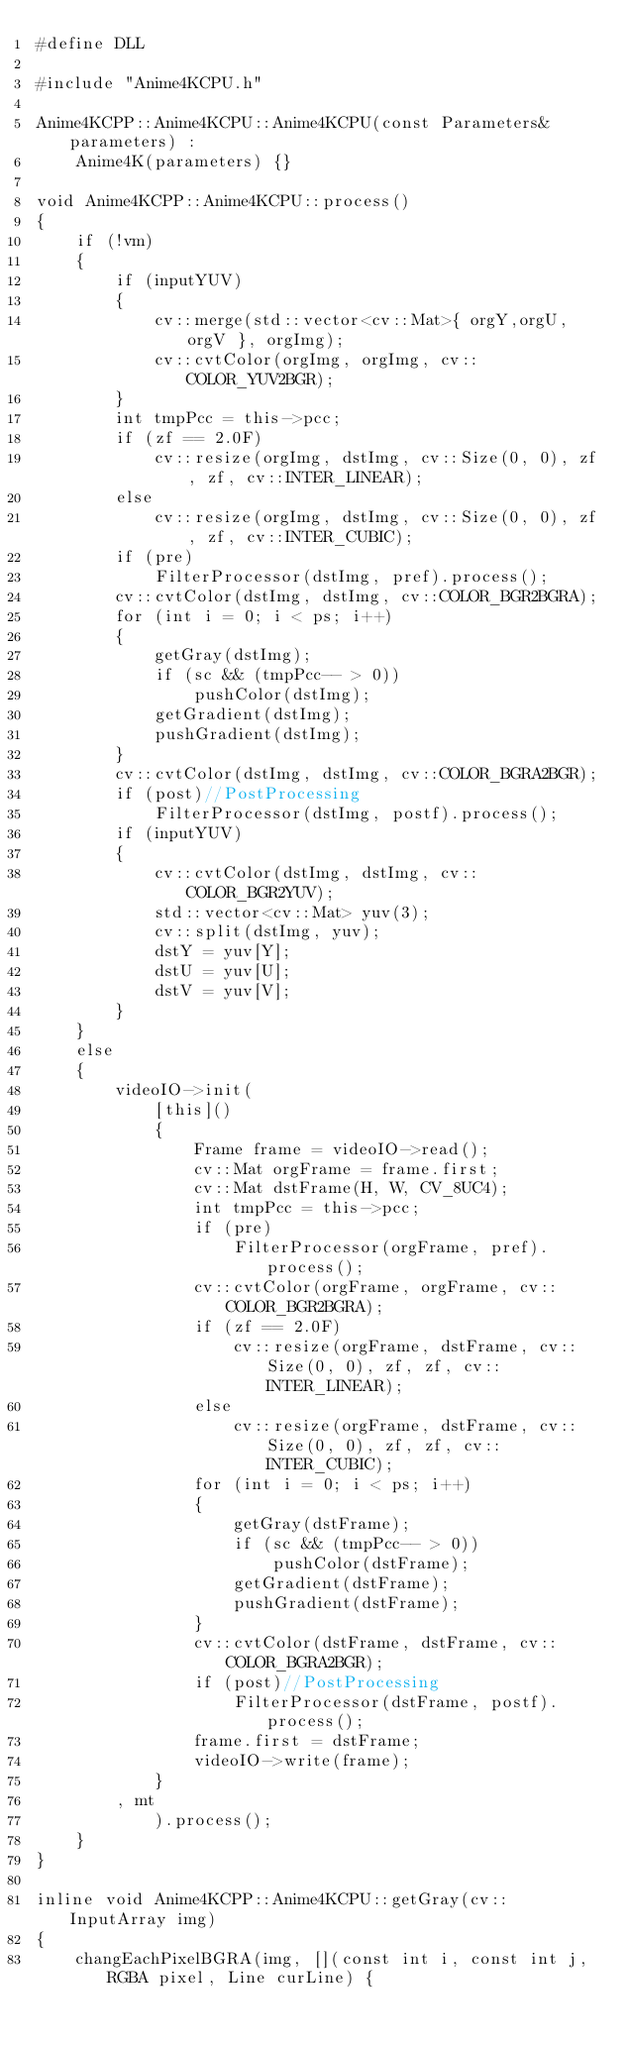<code> <loc_0><loc_0><loc_500><loc_500><_C++_>#define DLL

#include "Anime4KCPU.h"

Anime4KCPP::Anime4KCPU::Anime4KCPU(const Parameters& parameters) : 
    Anime4K(parameters) {}

void Anime4KCPP::Anime4KCPU::process()
{
    if (!vm)
    {
        if (inputYUV)
        {
            cv::merge(std::vector<cv::Mat>{ orgY,orgU,orgV }, orgImg);
            cv::cvtColor(orgImg, orgImg, cv::COLOR_YUV2BGR);
        }
        int tmpPcc = this->pcc;
        if (zf == 2.0F)
            cv::resize(orgImg, dstImg, cv::Size(0, 0), zf, zf, cv::INTER_LINEAR);
        else
            cv::resize(orgImg, dstImg, cv::Size(0, 0), zf, zf, cv::INTER_CUBIC);
        if (pre)
            FilterProcessor(dstImg, pref).process();
        cv::cvtColor(dstImg, dstImg, cv::COLOR_BGR2BGRA);
        for (int i = 0; i < ps; i++)
        {
            getGray(dstImg);
            if (sc && (tmpPcc-- > 0))
                pushColor(dstImg);
            getGradient(dstImg);
            pushGradient(dstImg);
        }
        cv::cvtColor(dstImg, dstImg, cv::COLOR_BGRA2BGR);
        if (post)//PostProcessing
            FilterProcessor(dstImg, postf).process();
        if (inputYUV)
        {
            cv::cvtColor(dstImg, dstImg, cv::COLOR_BGR2YUV);
            std::vector<cv::Mat> yuv(3);
            cv::split(dstImg, yuv);
            dstY = yuv[Y];
            dstU = yuv[U];
            dstV = yuv[V];
        }
    }
    else
    {
        videoIO->init(
            [this]()
            {
                Frame frame = videoIO->read();
                cv::Mat orgFrame = frame.first;
                cv::Mat dstFrame(H, W, CV_8UC4);
                int tmpPcc = this->pcc;
                if (pre)
                    FilterProcessor(orgFrame, pref).process();
                cv::cvtColor(orgFrame, orgFrame, cv::COLOR_BGR2BGRA);
                if (zf == 2.0F)
                    cv::resize(orgFrame, dstFrame, cv::Size(0, 0), zf, zf, cv::INTER_LINEAR);
                else
                    cv::resize(orgFrame, dstFrame, cv::Size(0, 0), zf, zf, cv::INTER_CUBIC);
                for (int i = 0; i < ps; i++)
                {
                    getGray(dstFrame);
                    if (sc && (tmpPcc-- > 0))
                        pushColor(dstFrame);
                    getGradient(dstFrame);
                    pushGradient(dstFrame);
                }
                cv::cvtColor(dstFrame, dstFrame, cv::COLOR_BGRA2BGR);
                if (post)//PostProcessing
                    FilterProcessor(dstFrame, postf).process();
                frame.first = dstFrame;
                videoIO->write(frame);
            }
        , mt
            ).process();
    }
}

inline void Anime4KCPP::Anime4KCPU::getGray(cv::InputArray img)
{
    changEachPixelBGRA(img, [](const int i, const int j, RGBA pixel, Line curLine) {</code> 